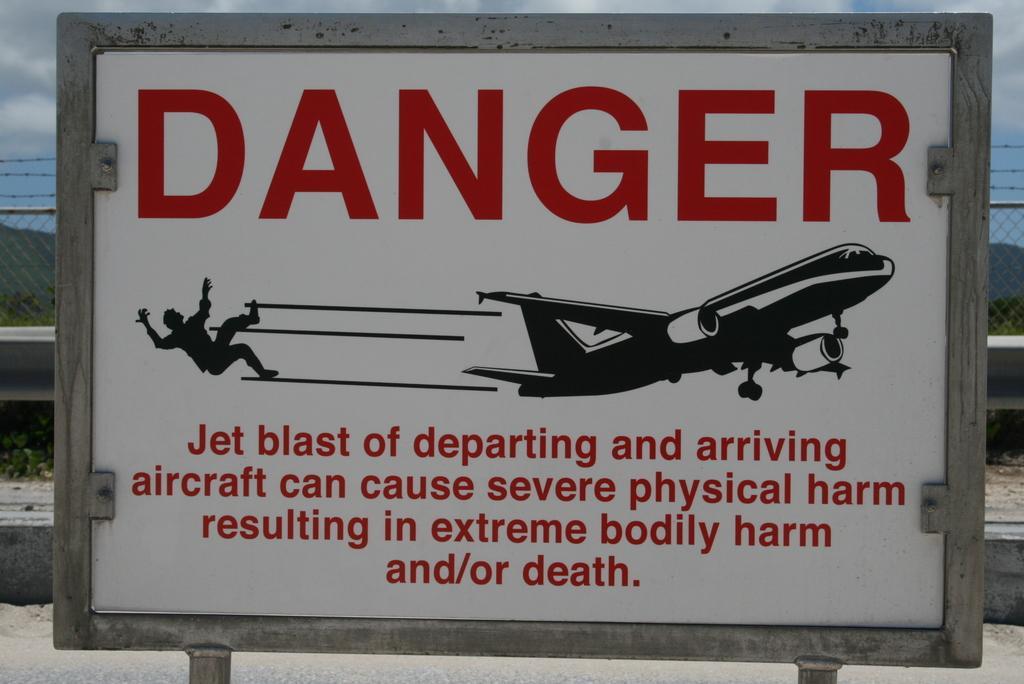Could you give a brief overview of what you see in this image? In this image I can see white color danger board. Background I can see railing, sky in white and blue color. 